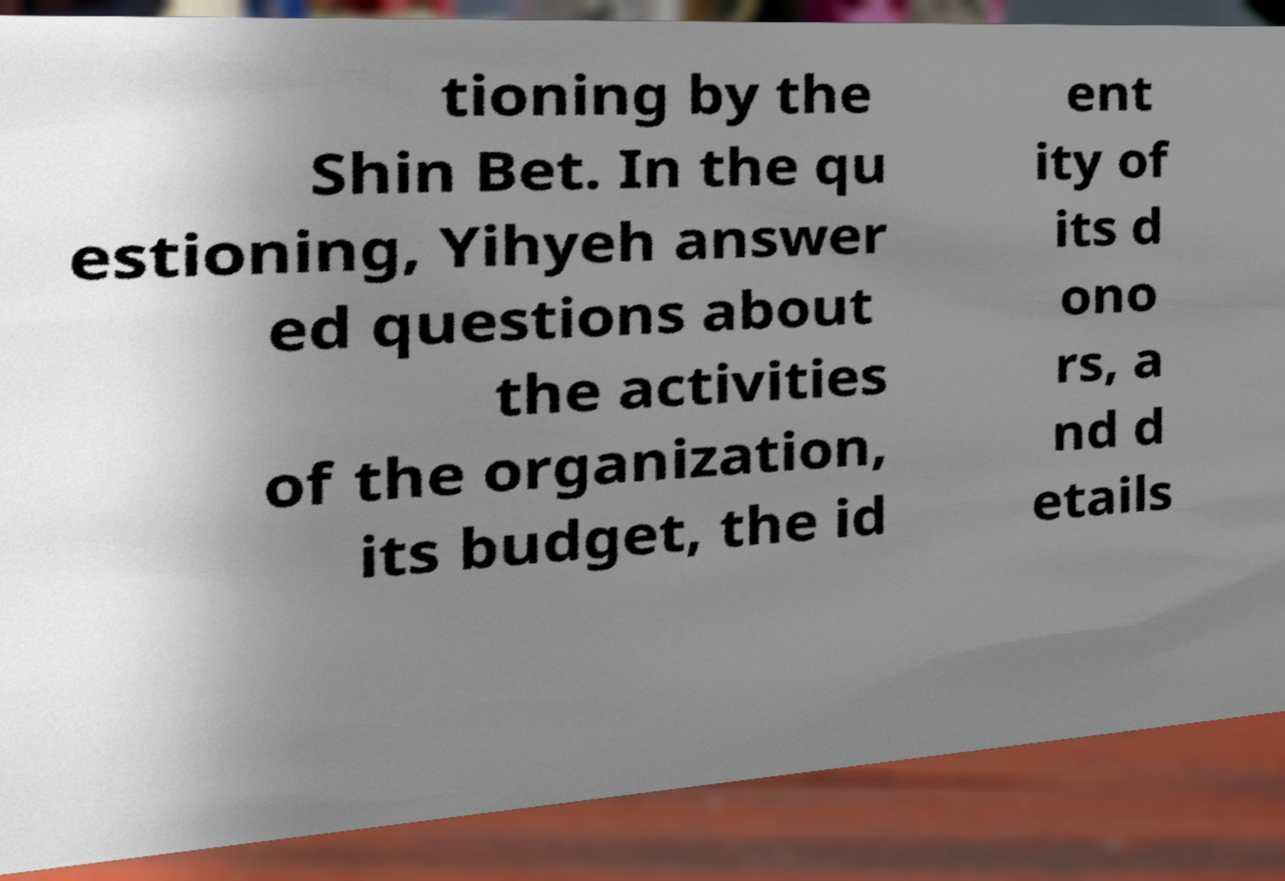There's text embedded in this image that I need extracted. Can you transcribe it verbatim? tioning by the Shin Bet. In the qu estioning, Yihyeh answer ed questions about the activities of the organization, its budget, the id ent ity of its d ono rs, a nd d etails 